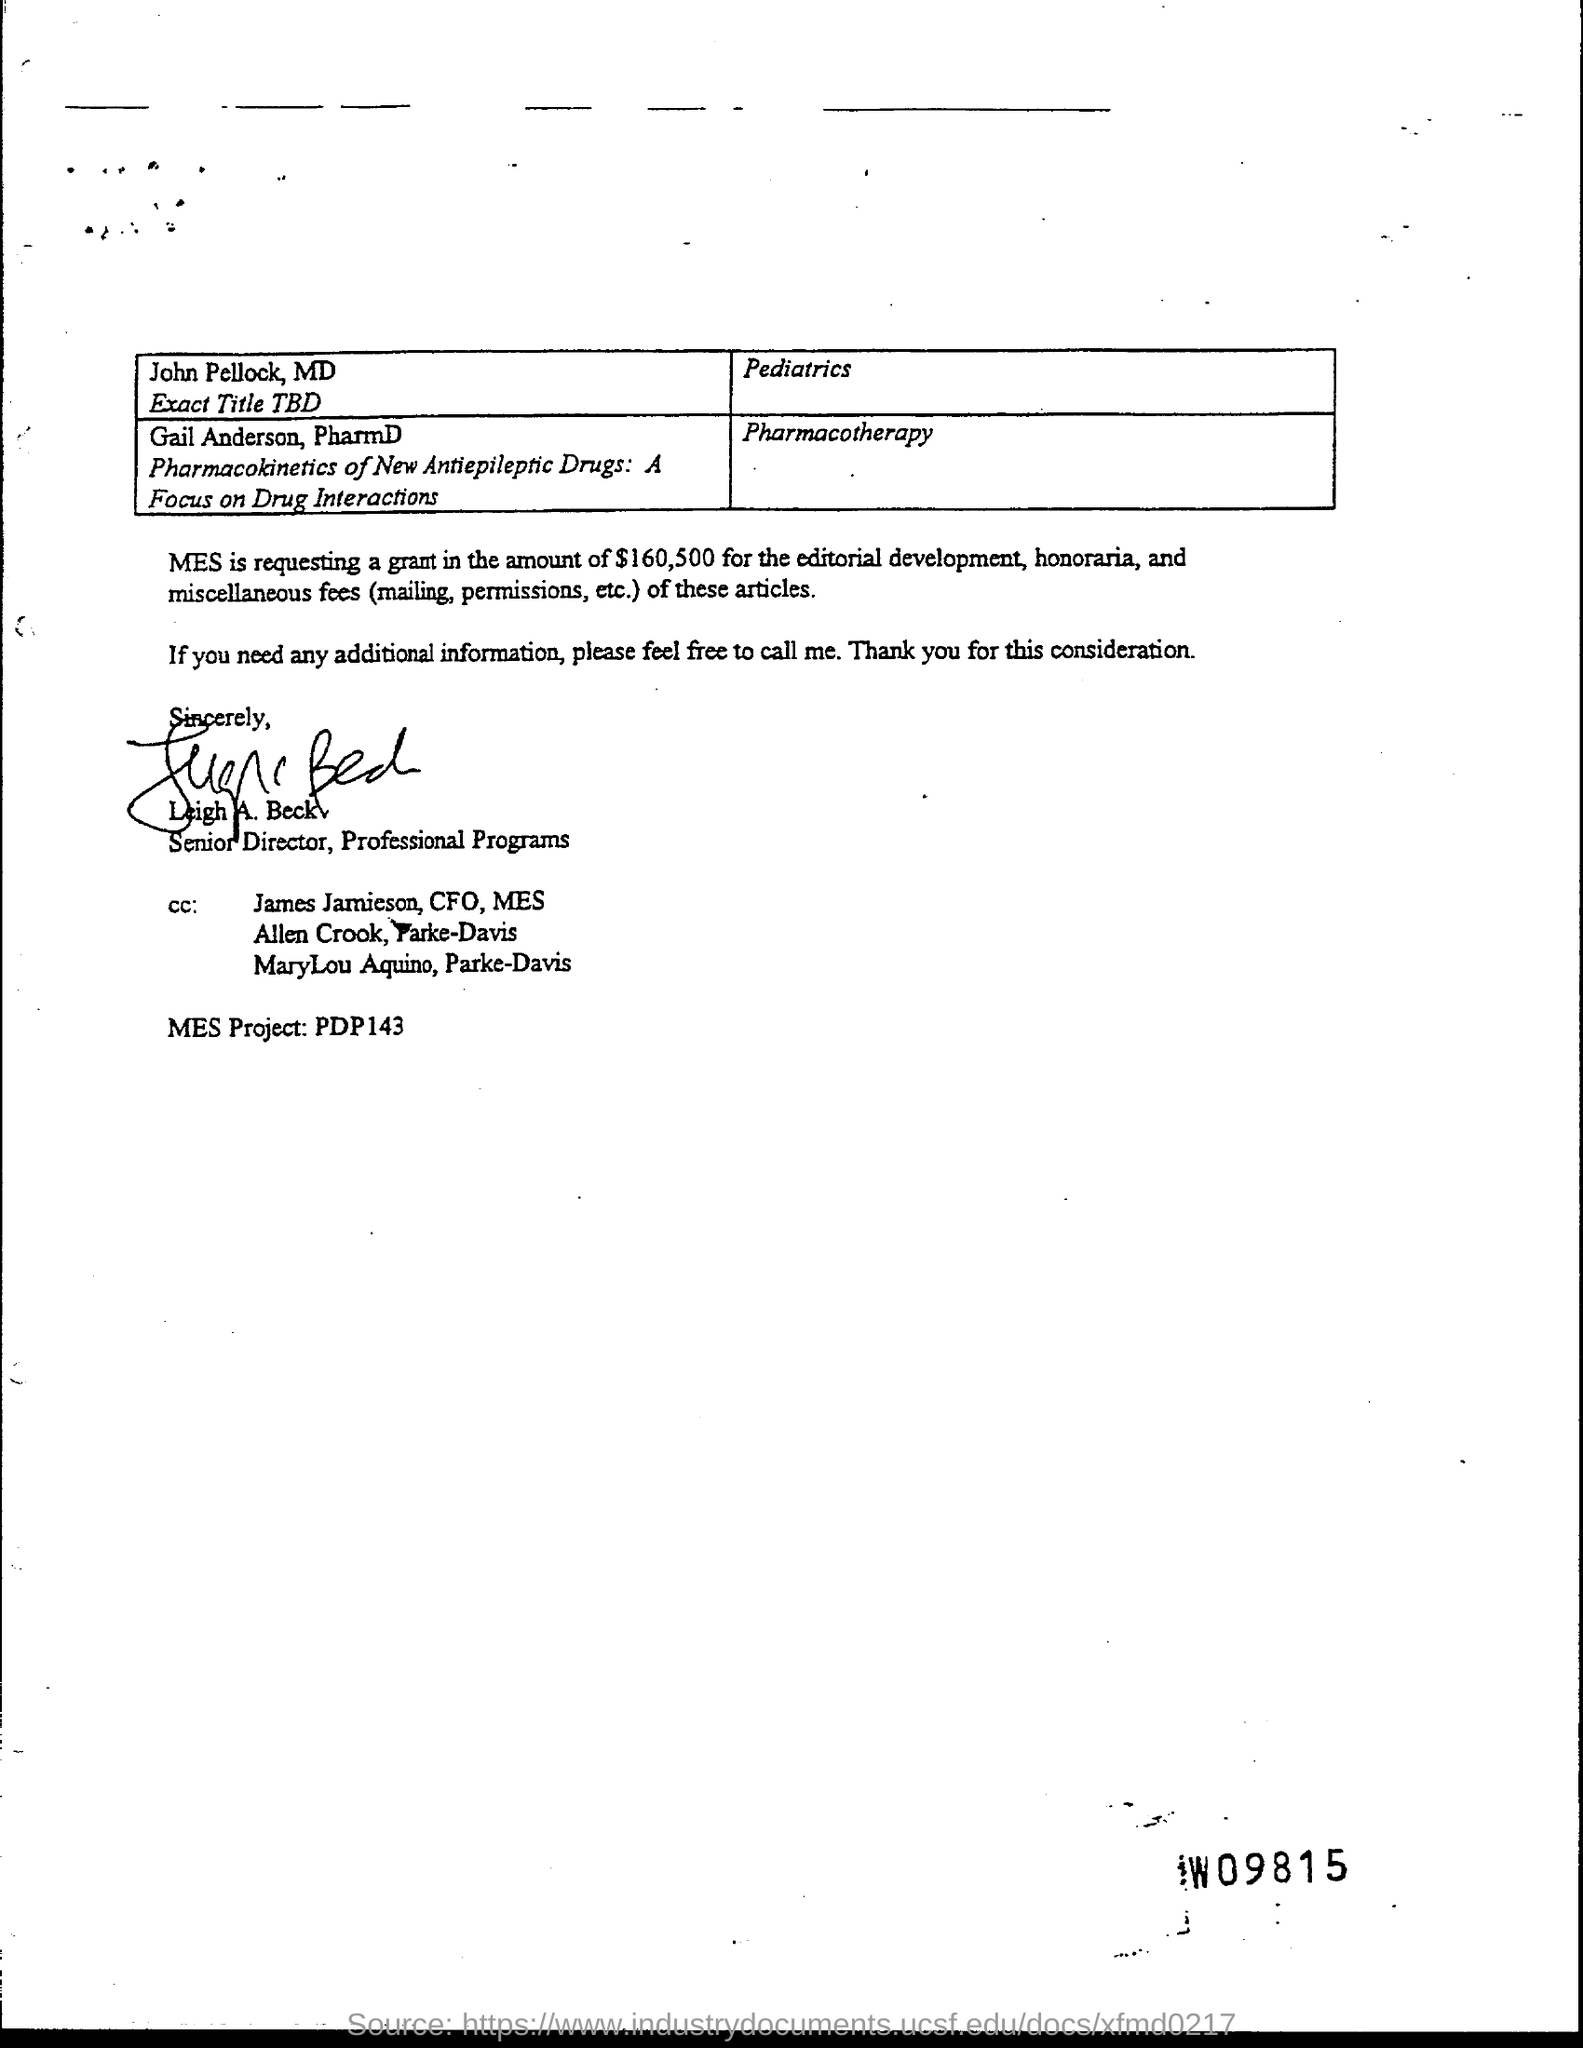Draw attention to some important aspects in this diagram. Leigh A. Beck holds the position of senior director. 